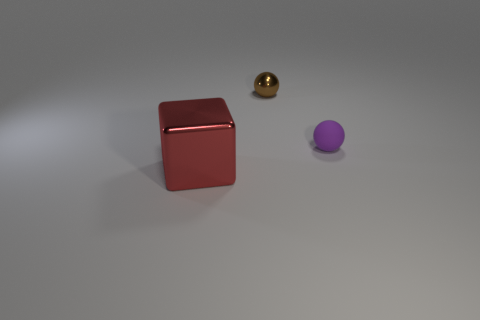How many things are either metal things on the right side of the red metal cube or objects that are in front of the rubber ball?
Offer a very short reply. 2. What material is the small brown object that is the same shape as the small purple object?
Your response must be concise. Metal. How many matte things are green cubes or purple balls?
Give a very brief answer. 1. What shape is the other thing that is the same material as the brown object?
Make the answer very short. Cube. How many other brown things are the same shape as the brown thing?
Keep it short and to the point. 0. There is a metal thing behind the purple object; does it have the same shape as the shiny thing to the left of the brown metallic object?
Provide a succinct answer. No. How many objects are cyan cylinders or small balls that are on the left side of the purple thing?
Keep it short and to the point. 1. What number of gray shiny things are the same size as the purple object?
Ensure brevity in your answer.  0. How many brown objects are large shiny blocks or metallic objects?
Your answer should be compact. 1. What is the shape of the shiny object on the right side of the large thing to the left of the brown ball?
Give a very brief answer. Sphere. 